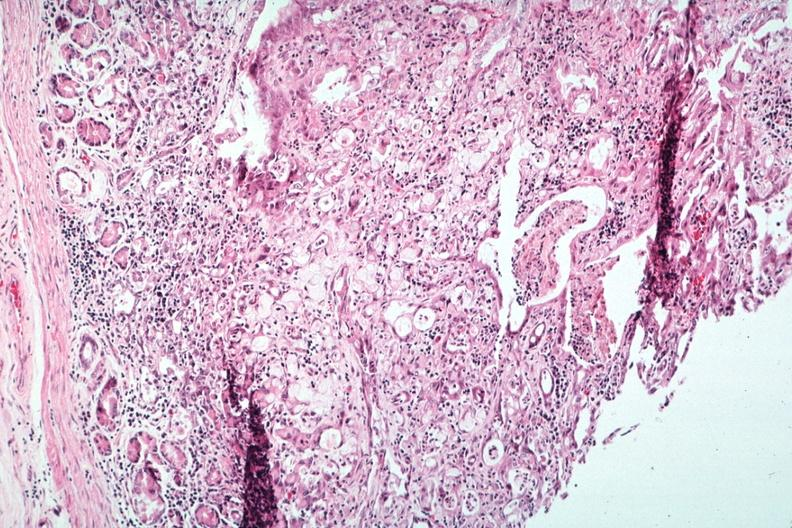what is present?
Answer the question using a single word or phrase. Lymph node 